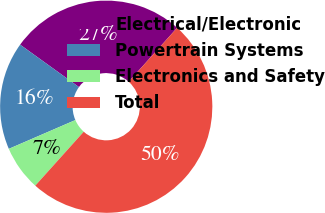Convert chart. <chart><loc_0><loc_0><loc_500><loc_500><pie_chart><fcel>Electrical/Electronic<fcel>Powertrain Systems<fcel>Electronics and Safety<fcel>Total<nl><fcel>26.71%<fcel>16.44%<fcel>6.85%<fcel>50.0%<nl></chart> 